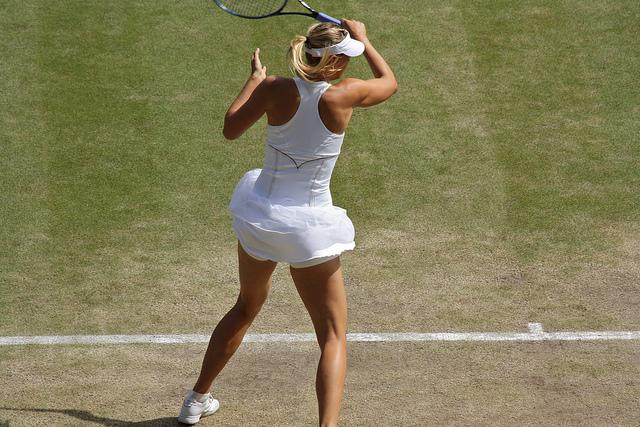What piece of equipment is missing from the picture?
Concise answer only. Ball. What sport is this?
Keep it brief. Tennis. What kind of court is she one?
Be succinct. Tennis. What is in her hand?
Give a very brief answer. Tennis racket. 